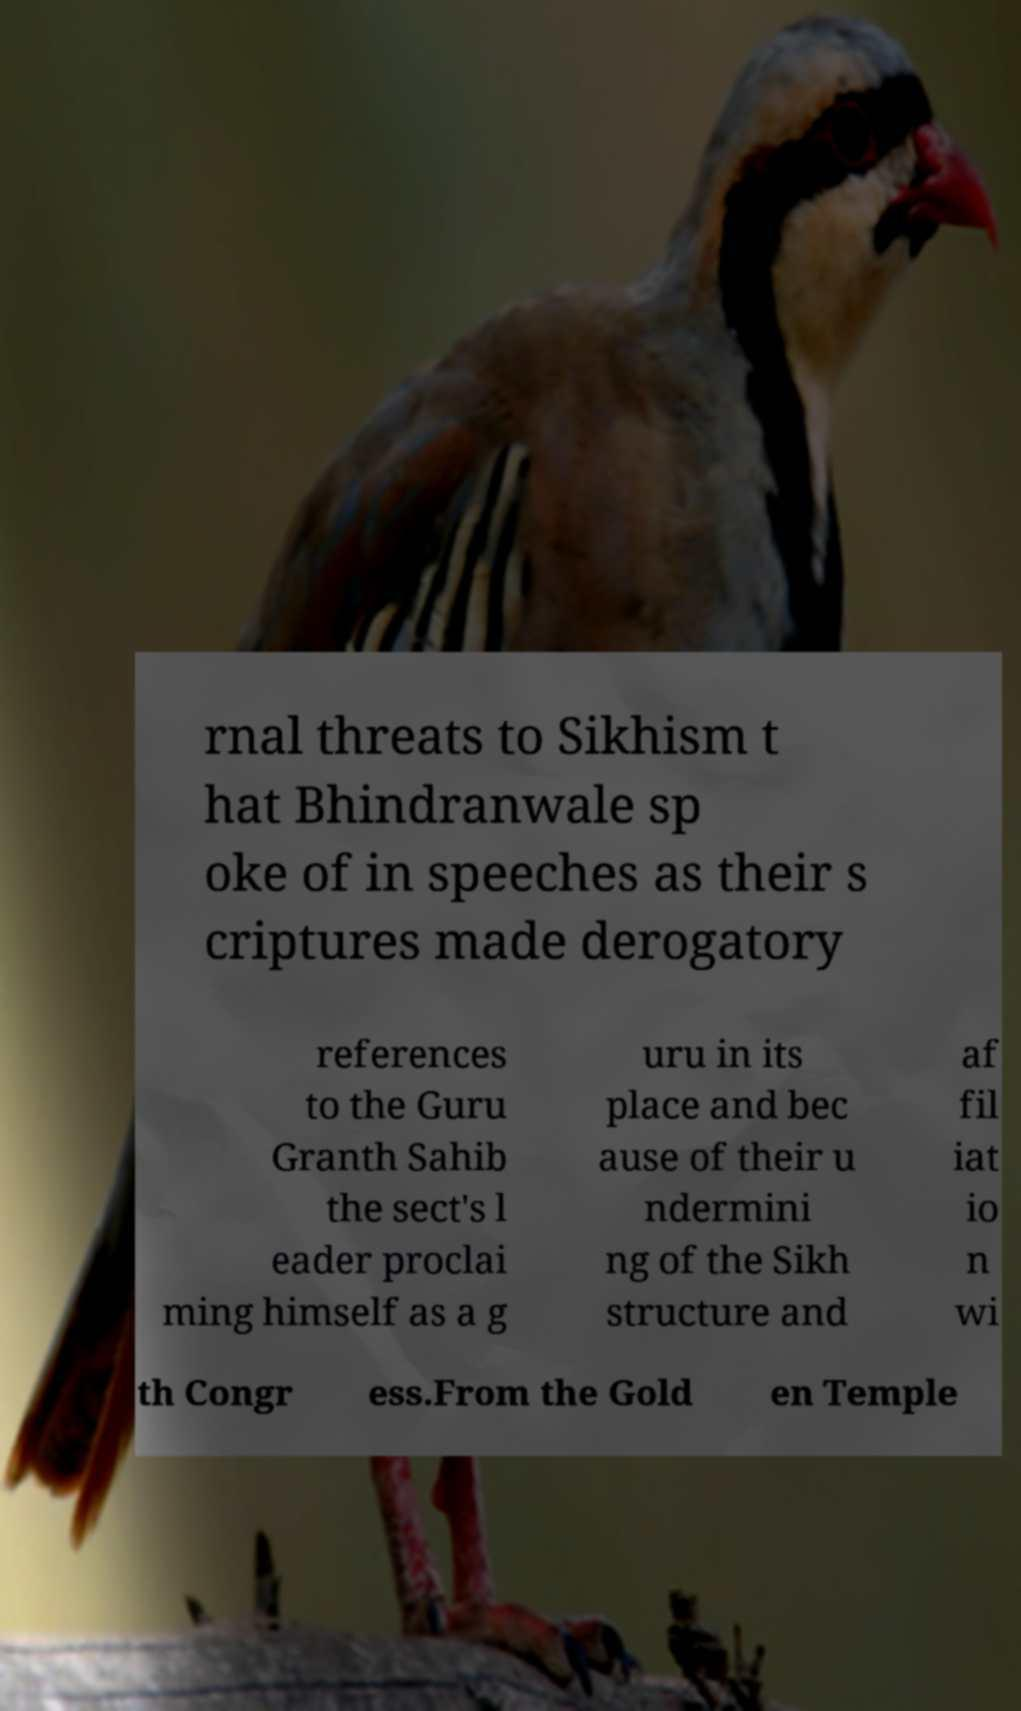For documentation purposes, I need the text within this image transcribed. Could you provide that? rnal threats to Sikhism t hat Bhindranwale sp oke of in speeches as their s criptures made derogatory references to the Guru Granth Sahib the sect's l eader proclai ming himself as a g uru in its place and bec ause of their u ndermini ng of the Sikh structure and af fil iat io n wi th Congr ess.From the Gold en Temple 